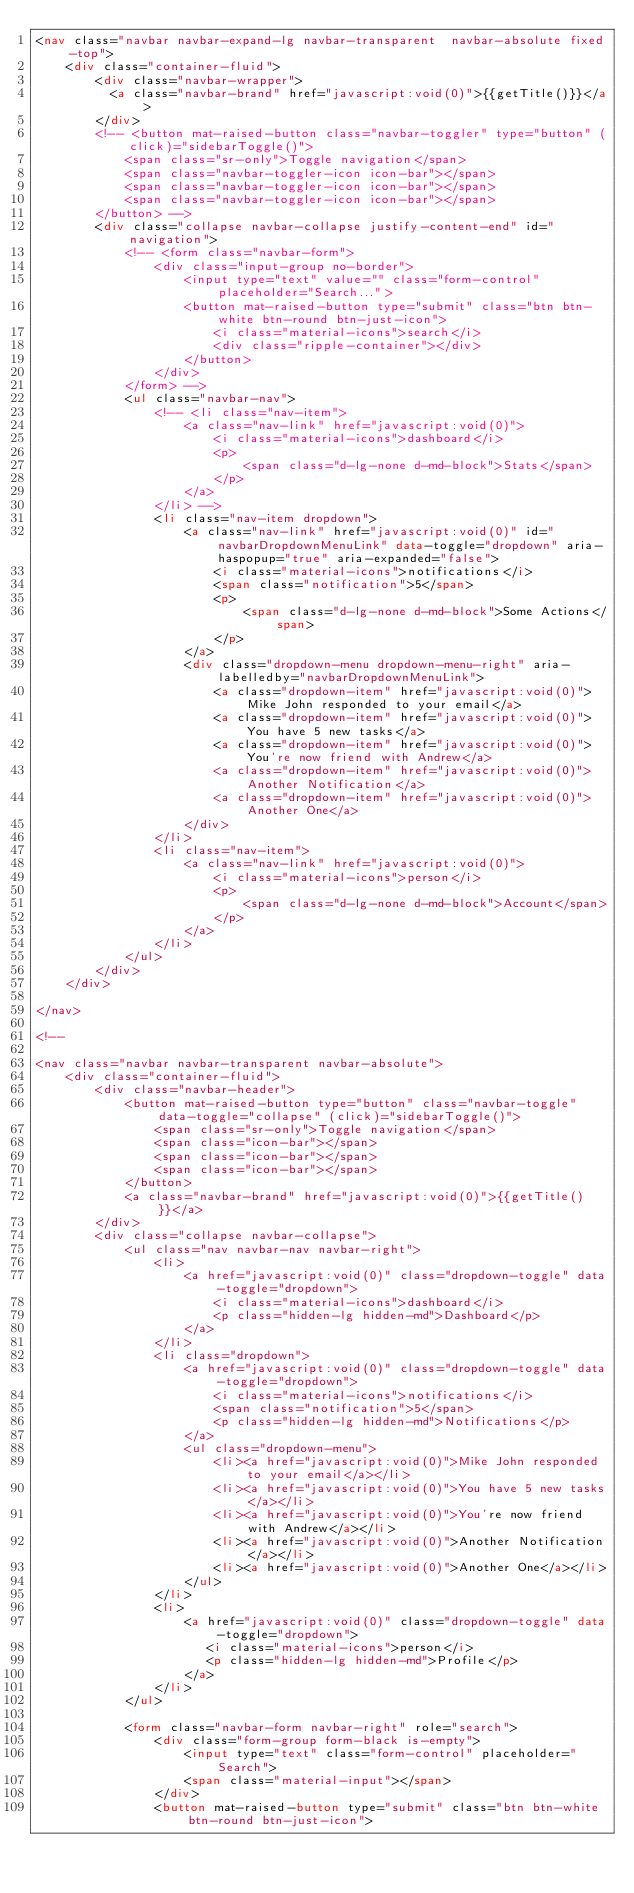<code> <loc_0><loc_0><loc_500><loc_500><_HTML_><nav class="navbar navbar-expand-lg navbar-transparent  navbar-absolute fixed-top">
    <div class="container-fluid">
        <div class="navbar-wrapper">
          <a class="navbar-brand" href="javascript:void(0)">{{getTitle()}}</a>
        </div>
        <!-- <button mat-raised-button class="navbar-toggler" type="button" (click)="sidebarToggle()">
            <span class="sr-only">Toggle navigation</span>
            <span class="navbar-toggler-icon icon-bar"></span>
            <span class="navbar-toggler-icon icon-bar"></span>
            <span class="navbar-toggler-icon icon-bar"></span>
        </button> -->
        <div class="collapse navbar-collapse justify-content-end" id="navigation">
            <!-- <form class="navbar-form">
                <div class="input-group no-border">
                    <input type="text" value="" class="form-control" placeholder="Search...">
                    <button mat-raised-button type="submit" class="btn btn-white btn-round btn-just-icon">
                        <i class="material-icons">search</i>
                        <div class="ripple-container"></div>
                    </button>
                </div>
            </form> -->
            <ul class="navbar-nav">
                <!-- <li class="nav-item">
                    <a class="nav-link" href="javascript:void(0)">
                        <i class="material-icons">dashboard</i>
                        <p>
                            <span class="d-lg-none d-md-block">Stats</span>
                        </p>
                    </a>
                </li> -->
                <li class="nav-item dropdown">
                    <a class="nav-link" href="javascript:void(0)" id="navbarDropdownMenuLink" data-toggle="dropdown" aria-haspopup="true" aria-expanded="false">
                        <i class="material-icons">notifications</i>
                        <span class="notification">5</span>
                        <p>
                            <span class="d-lg-none d-md-block">Some Actions</span>
                        </p>
                    </a>
                    <div class="dropdown-menu dropdown-menu-right" aria-labelledby="navbarDropdownMenuLink">
                        <a class="dropdown-item" href="javascript:void(0)">Mike John responded to your email</a>
                        <a class="dropdown-item" href="javascript:void(0)">You have 5 new tasks</a>
                        <a class="dropdown-item" href="javascript:void(0)">You're now friend with Andrew</a>
                        <a class="dropdown-item" href="javascript:void(0)">Another Notification</a>
                        <a class="dropdown-item" href="javascript:void(0)">Another One</a>
                    </div>
                </li>
                <li class="nav-item">
                    <a class="nav-link" href="javascript:void(0)">
                        <i class="material-icons">person</i>
                        <p>
                            <span class="d-lg-none d-md-block">Account</span>
                        </p>
                    </a>
                </li>
            </ul>
        </div>
    </div>
    
</nav>

<!--

<nav class="navbar navbar-transparent navbar-absolute">
    <div class="container-fluid">
        <div class="navbar-header">
            <button mat-raised-button type="button" class="navbar-toggle" data-toggle="collapse" (click)="sidebarToggle()">
                <span class="sr-only">Toggle navigation</span>
                <span class="icon-bar"></span>
                <span class="icon-bar"></span>
                <span class="icon-bar"></span>
            </button>
            <a class="navbar-brand" href="javascript:void(0)">{{getTitle()}}</a>
        </div>
        <div class="collapse navbar-collapse">
            <ul class="nav navbar-nav navbar-right">
                <li>
                    <a href="javascript:void(0)" class="dropdown-toggle" data-toggle="dropdown">
                        <i class="material-icons">dashboard</i>
                        <p class="hidden-lg hidden-md">Dashboard</p>
                    </a>
                </li>
                <li class="dropdown">
                    <a href="javascript:void(0)" class="dropdown-toggle" data-toggle="dropdown">
                        <i class="material-icons">notifications</i>
                        <span class="notification">5</span>
                        <p class="hidden-lg hidden-md">Notifications</p>
                    </a>
                    <ul class="dropdown-menu">
                        <li><a href="javascript:void(0)">Mike John responded to your email</a></li>
                        <li><a href="javascript:void(0)">You have 5 new tasks</a></li>
                        <li><a href="javascript:void(0)">You're now friend with Andrew</a></li>
                        <li><a href="javascript:void(0)">Another Notification</a></li>
                        <li><a href="javascript:void(0)">Another One</a></li>
                    </ul>
                </li>
                <li>
                    <a href="javascript:void(0)" class="dropdown-toggle" data-toggle="dropdown">
                       <i class="material-icons">person</i>
                       <p class="hidden-lg hidden-md">Profile</p>
                    </a>
                </li>
            </ul>

            <form class="navbar-form navbar-right" role="search">
                <div class="form-group form-black is-empty">
                    <input type="text" class="form-control" placeholder="Search">
                    <span class="material-input"></span>
                </div>
                <button mat-raised-button type="submit" class="btn btn-white btn-round btn-just-icon"></code> 